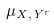<formula> <loc_0><loc_0><loc_500><loc_500>\mu _ { X , Y ^ { r } }</formula> 